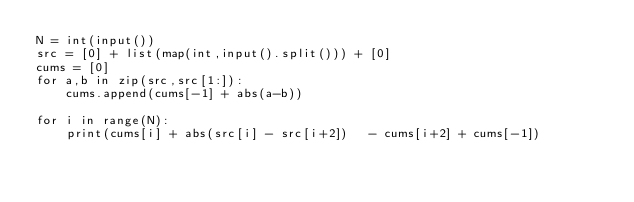Convert code to text. <code><loc_0><loc_0><loc_500><loc_500><_Python_>N = int(input())
src = [0] + list(map(int,input().split())) + [0]
cums = [0]
for a,b in zip(src,src[1:]):
    cums.append(cums[-1] + abs(a-b))

for i in range(N):
    print(cums[i] + abs(src[i] - src[i+2])   - cums[i+2] + cums[-1])
</code> 